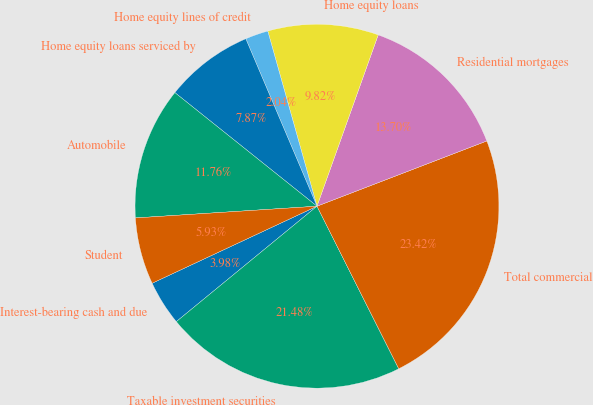Convert chart to OTSL. <chart><loc_0><loc_0><loc_500><loc_500><pie_chart><fcel>Interest-bearing cash and due<fcel>Taxable investment securities<fcel>Total commercial<fcel>Residential mortgages<fcel>Home equity loans<fcel>Home equity lines of credit<fcel>Home equity loans serviced by<fcel>Automobile<fcel>Student<nl><fcel>3.98%<fcel>21.48%<fcel>23.42%<fcel>13.7%<fcel>9.82%<fcel>2.04%<fcel>7.87%<fcel>11.76%<fcel>5.93%<nl></chart> 